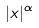Convert formula to latex. <formula><loc_0><loc_0><loc_500><loc_500>| x | ^ { \alpha }</formula> 